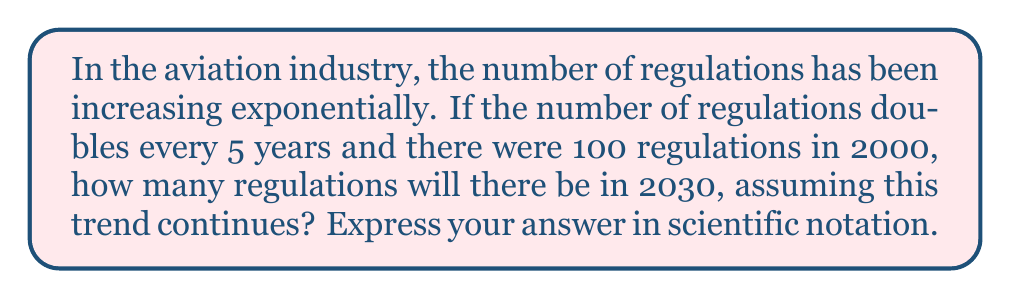Solve this math problem. Let's approach this step-by-step:

1) First, we need to determine how many 5-year periods are between 2000 and 2030:
   $\frac{2030 - 2000}{5} = 6$ periods

2) We know that the number of regulations doubles every 5 years. This means we're dealing with exponential growth with a base of 2:

   $100 \cdot 2^6$

3) Let's calculate this:
   $100 \cdot 2^6 = 100 \cdot 64 = 6400$

4) To express this in scientific notation, we move the decimal point to the left until we have a number between 1 and 10, and then count how many places we moved:

   $6400 = 6.4 \cdot 10^3$

Therefore, assuming the trend continues, there will be $6.4 \cdot 10^3$ regulations in 2030.
Answer: $6.4 \cdot 10^3$ 